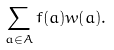Convert formula to latex. <formula><loc_0><loc_0><loc_500><loc_500>\sum _ { a \in A } f ( a ) w ( a ) .</formula> 